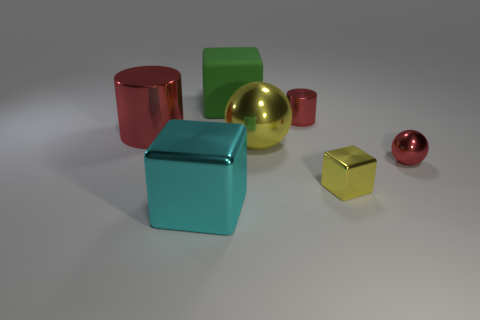Subtract all red balls. How many balls are left? 1 Subtract all cyan metal blocks. How many blocks are left? 2 Add 2 tiny shiny objects. How many objects exist? 9 Subtract all blocks. How many objects are left? 4 Subtract all yellow cubes. Subtract all small red things. How many objects are left? 4 Add 1 big yellow objects. How many big yellow objects are left? 2 Add 4 big green balls. How many big green balls exist? 4 Subtract 0 blue spheres. How many objects are left? 7 Subtract 1 spheres. How many spheres are left? 1 Subtract all yellow blocks. Subtract all blue cylinders. How many blocks are left? 2 